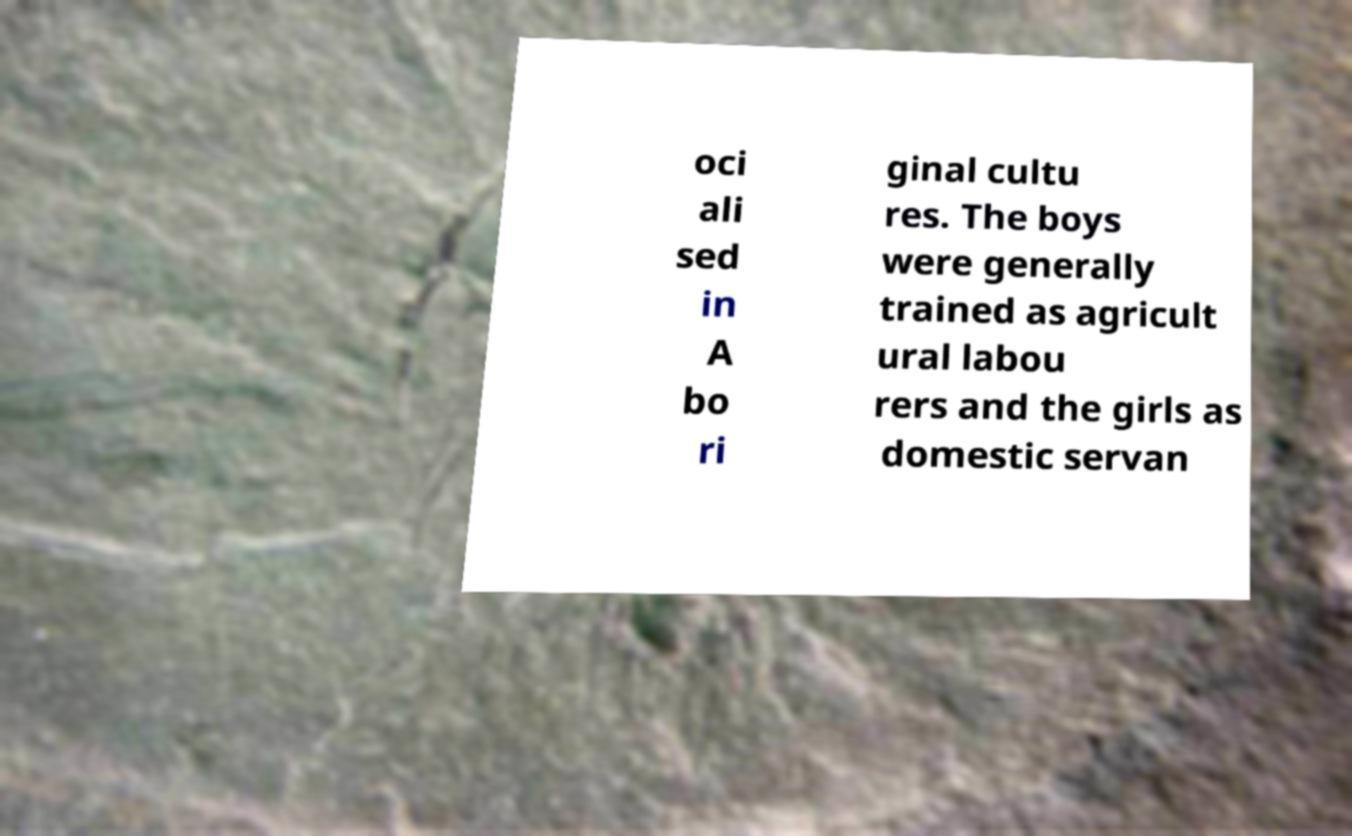Please read and relay the text visible in this image. What does it say? oci ali sed in A bo ri ginal cultu res. The boys were generally trained as agricult ural labou rers and the girls as domestic servan 